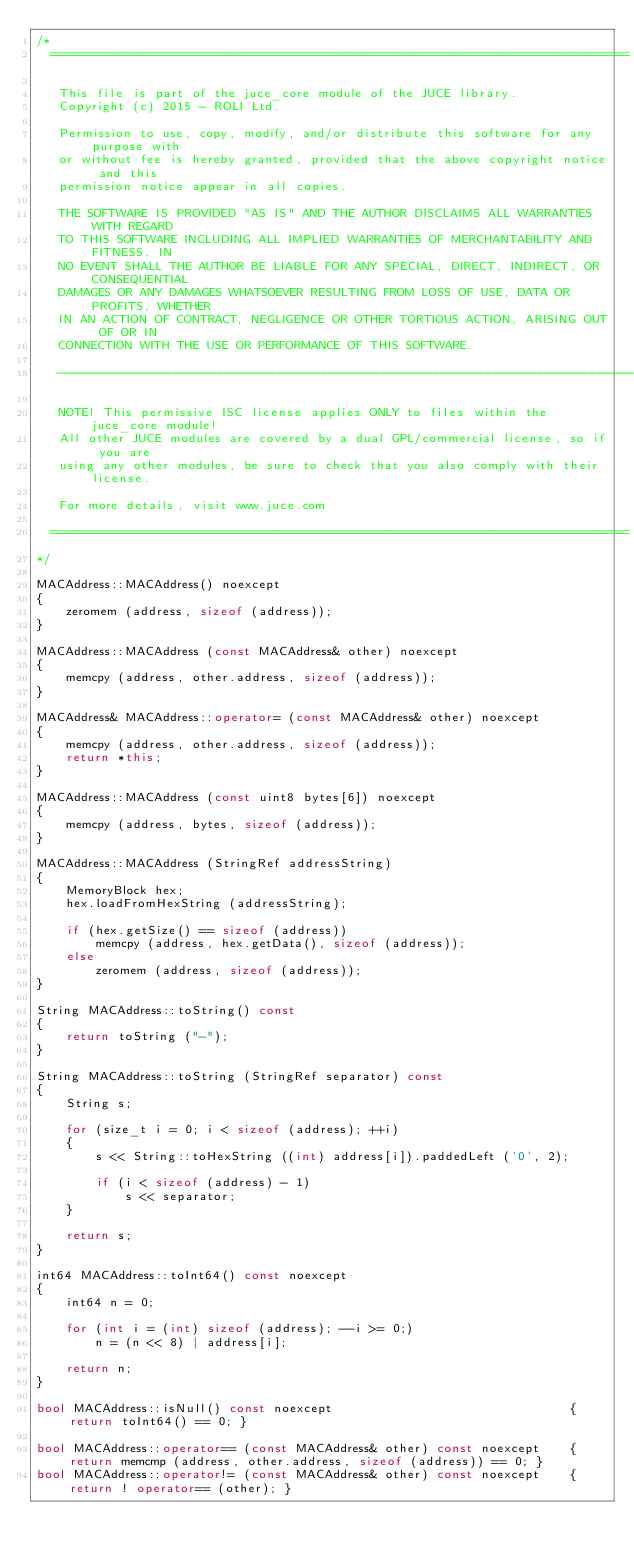<code> <loc_0><loc_0><loc_500><loc_500><_C++_>/*
  ==============================================================================

   This file is part of the juce_core module of the JUCE library.
   Copyright (c) 2015 - ROLI Ltd.

   Permission to use, copy, modify, and/or distribute this software for any purpose with
   or without fee is hereby granted, provided that the above copyright notice and this
   permission notice appear in all copies.

   THE SOFTWARE IS PROVIDED "AS IS" AND THE AUTHOR DISCLAIMS ALL WARRANTIES WITH REGARD
   TO THIS SOFTWARE INCLUDING ALL IMPLIED WARRANTIES OF MERCHANTABILITY AND FITNESS. IN
   NO EVENT SHALL THE AUTHOR BE LIABLE FOR ANY SPECIAL, DIRECT, INDIRECT, OR CONSEQUENTIAL
   DAMAGES OR ANY DAMAGES WHATSOEVER RESULTING FROM LOSS OF USE, DATA OR PROFITS, WHETHER
   IN AN ACTION OF CONTRACT, NEGLIGENCE OR OTHER TORTIOUS ACTION, ARISING OUT OF OR IN
   CONNECTION WITH THE USE OR PERFORMANCE OF THIS SOFTWARE.

   ------------------------------------------------------------------------------

   NOTE! This permissive ISC license applies ONLY to files within the juce_core module!
   All other JUCE modules are covered by a dual GPL/commercial license, so if you are
   using any other modules, be sure to check that you also comply with their license.

   For more details, visit www.juce.com

  ==============================================================================
*/

MACAddress::MACAddress() noexcept
{
    zeromem (address, sizeof (address));
}

MACAddress::MACAddress (const MACAddress& other) noexcept
{
    memcpy (address, other.address, sizeof (address));
}

MACAddress& MACAddress::operator= (const MACAddress& other) noexcept
{
    memcpy (address, other.address, sizeof (address));
    return *this;
}

MACAddress::MACAddress (const uint8 bytes[6]) noexcept
{
    memcpy (address, bytes, sizeof (address));
}

MACAddress::MACAddress (StringRef addressString)
{
    MemoryBlock hex;
    hex.loadFromHexString (addressString);

    if (hex.getSize() == sizeof (address))
        memcpy (address, hex.getData(), sizeof (address));
    else
        zeromem (address, sizeof (address));
}

String MACAddress::toString() const
{
    return toString ("-");
}

String MACAddress::toString (StringRef separator) const
{
    String s;

    for (size_t i = 0; i < sizeof (address); ++i)
    {
        s << String::toHexString ((int) address[i]).paddedLeft ('0', 2);

        if (i < sizeof (address) - 1)
            s << separator;
    }

    return s;
}

int64 MACAddress::toInt64() const noexcept
{
    int64 n = 0;

    for (int i = (int) sizeof (address); --i >= 0;)
        n = (n << 8) | address[i];

    return n;
}

bool MACAddress::isNull() const noexcept                                { return toInt64() == 0; }

bool MACAddress::operator== (const MACAddress& other) const noexcept    { return memcmp (address, other.address, sizeof (address)) == 0; }
bool MACAddress::operator!= (const MACAddress& other) const noexcept    { return ! operator== (other); }
</code> 